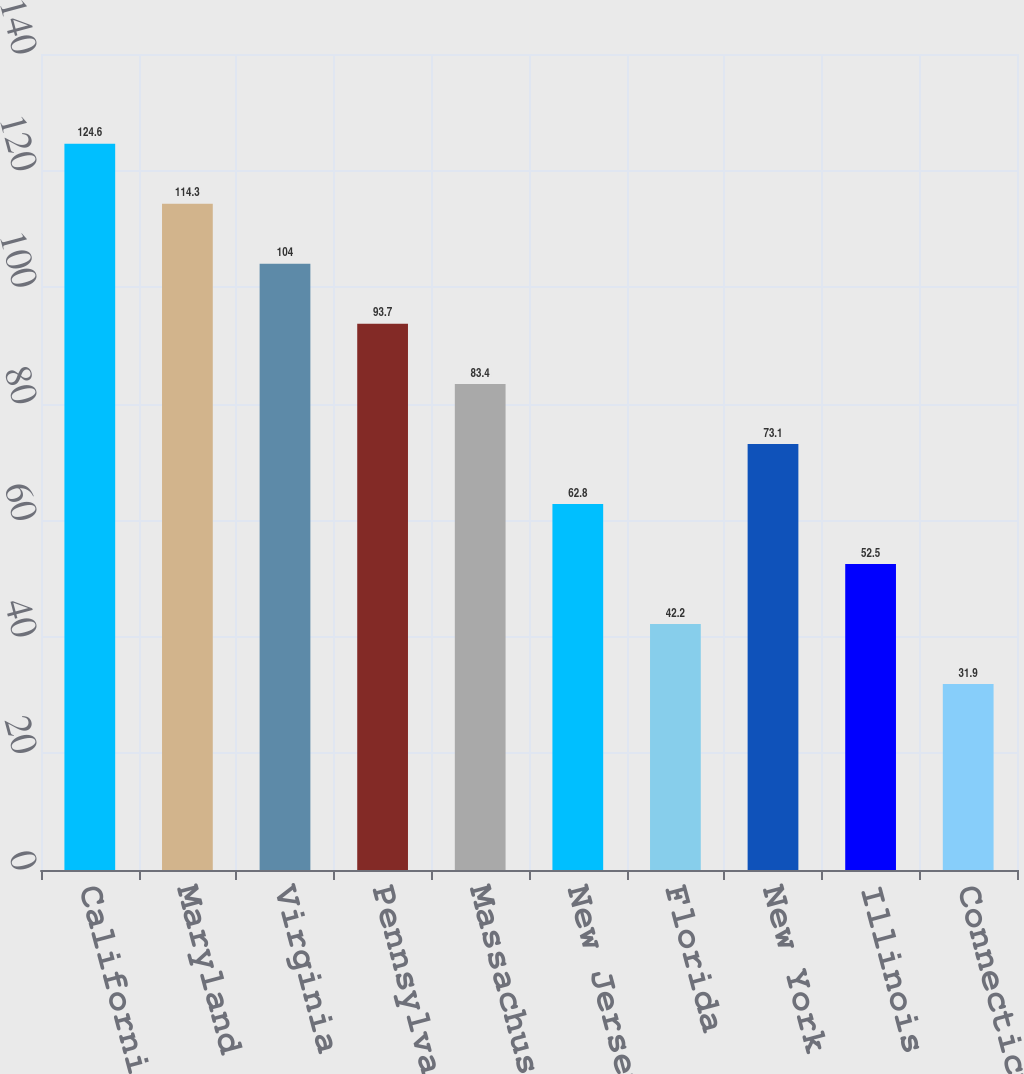Convert chart. <chart><loc_0><loc_0><loc_500><loc_500><bar_chart><fcel>California<fcel>Maryland<fcel>Virginia<fcel>Pennsylvania(1)<fcel>Massachusetts<fcel>New Jersey<fcel>Florida<fcel>New York<fcel>Illinois<fcel>Connecticut<nl><fcel>124.6<fcel>114.3<fcel>104<fcel>93.7<fcel>83.4<fcel>62.8<fcel>42.2<fcel>73.1<fcel>52.5<fcel>31.9<nl></chart> 